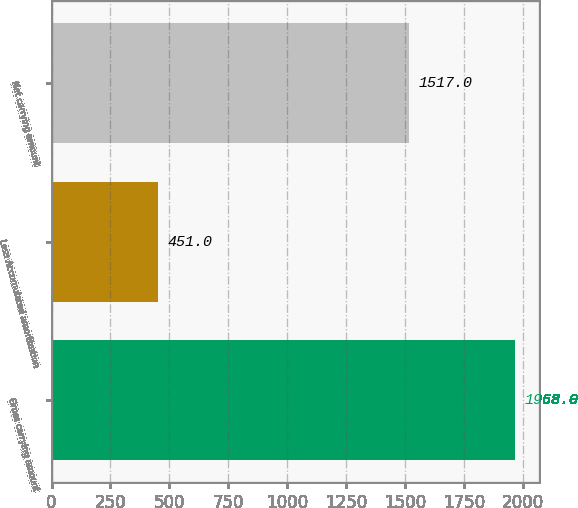<chart> <loc_0><loc_0><loc_500><loc_500><bar_chart><fcel>Gross carrying amount<fcel>Less Accumulated amortization<fcel>Net carrying amount<nl><fcel>1968<fcel>451<fcel>1517<nl></chart> 